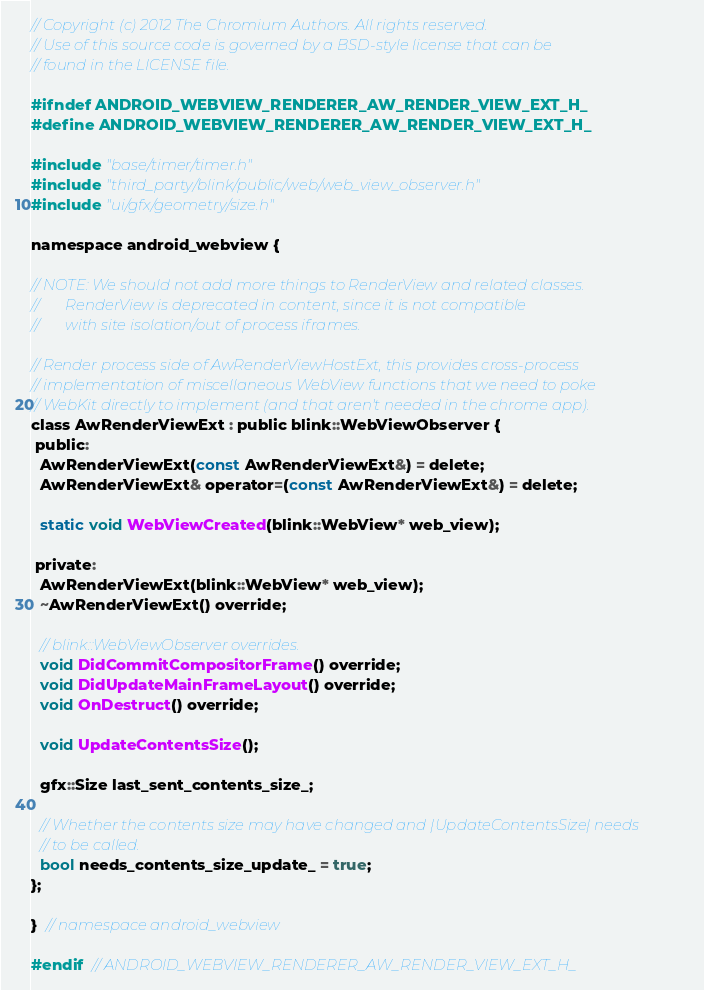<code> <loc_0><loc_0><loc_500><loc_500><_C_>// Copyright (c) 2012 The Chromium Authors. All rights reserved.
// Use of this source code is governed by a BSD-style license that can be
// found in the LICENSE file.

#ifndef ANDROID_WEBVIEW_RENDERER_AW_RENDER_VIEW_EXT_H_
#define ANDROID_WEBVIEW_RENDERER_AW_RENDER_VIEW_EXT_H_

#include "base/timer/timer.h"
#include "third_party/blink/public/web/web_view_observer.h"
#include "ui/gfx/geometry/size.h"

namespace android_webview {

// NOTE: We should not add more things to RenderView and related classes.
//       RenderView is deprecated in content, since it is not compatible
//       with site isolation/out of process iframes.

// Render process side of AwRenderViewHostExt, this provides cross-process
// implementation of miscellaneous WebView functions that we need to poke
// WebKit directly to implement (and that aren't needed in the chrome app).
class AwRenderViewExt : public blink::WebViewObserver {
 public:
  AwRenderViewExt(const AwRenderViewExt&) = delete;
  AwRenderViewExt& operator=(const AwRenderViewExt&) = delete;

  static void WebViewCreated(blink::WebView* web_view);

 private:
  AwRenderViewExt(blink::WebView* web_view);
  ~AwRenderViewExt() override;

  // blink::WebViewObserver overrides.
  void DidCommitCompositorFrame() override;
  void DidUpdateMainFrameLayout() override;
  void OnDestruct() override;

  void UpdateContentsSize();

  gfx::Size last_sent_contents_size_;

  // Whether the contents size may have changed and |UpdateContentsSize| needs
  // to be called.
  bool needs_contents_size_update_ = true;
};

}  // namespace android_webview

#endif  // ANDROID_WEBVIEW_RENDERER_AW_RENDER_VIEW_EXT_H_
</code> 